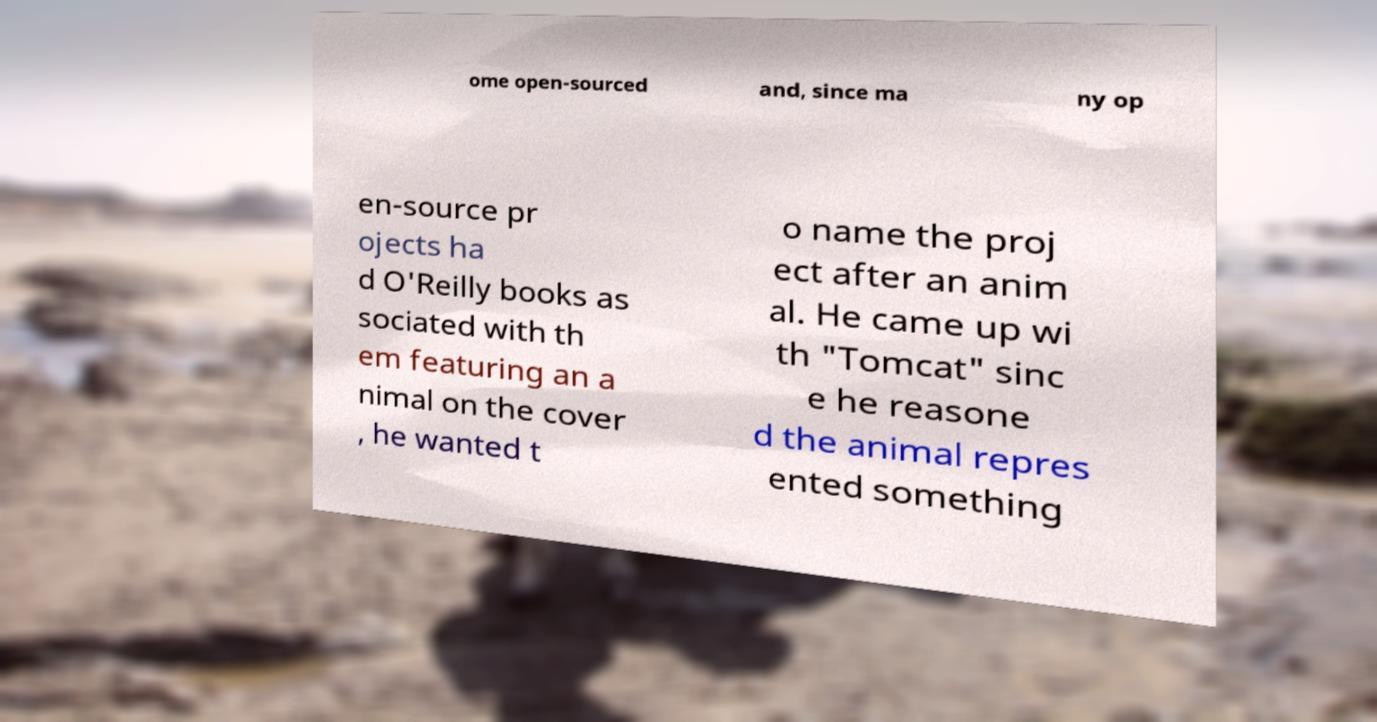Could you assist in decoding the text presented in this image and type it out clearly? ome open-sourced and, since ma ny op en-source pr ojects ha d O'Reilly books as sociated with th em featuring an a nimal on the cover , he wanted t o name the proj ect after an anim al. He came up wi th "Tomcat" sinc e he reasone d the animal repres ented something 